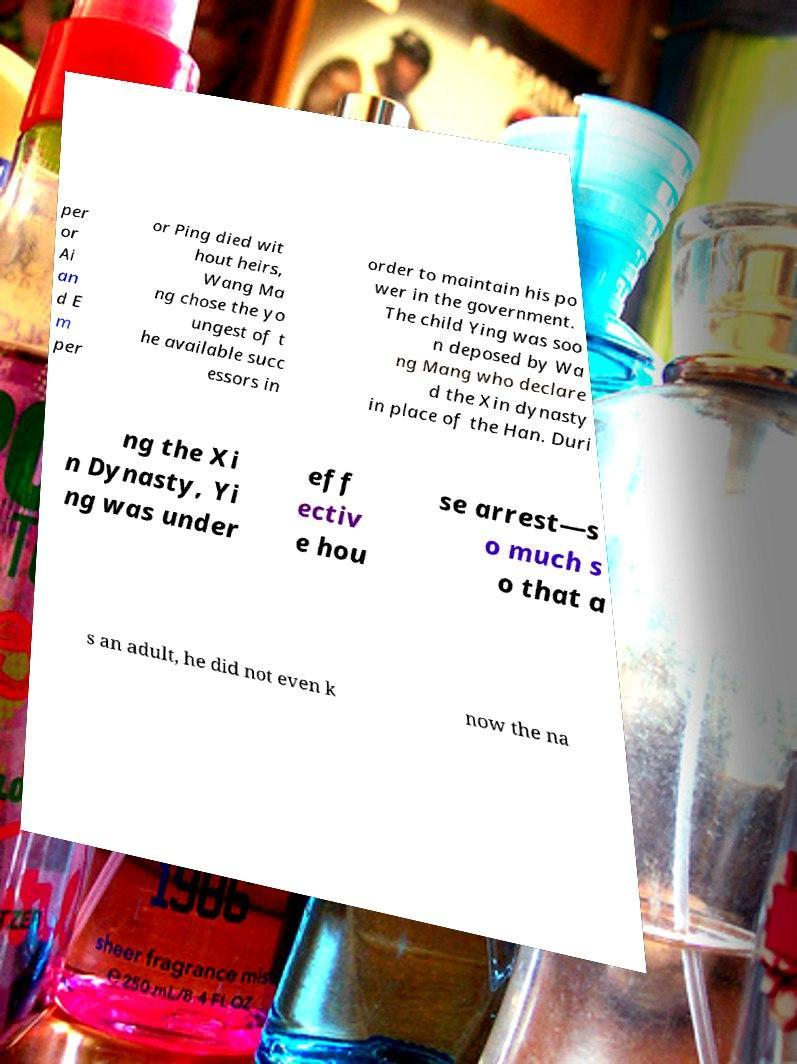I need the written content from this picture converted into text. Can you do that? per or Ai an d E m per or Ping died wit hout heirs, Wang Ma ng chose the yo ungest of t he available succ essors in order to maintain his po wer in the government. The child Ying was soo n deposed by Wa ng Mang who declare d the Xin dynasty in place of the Han. Duri ng the Xi n Dynasty, Yi ng was under eff ectiv e hou se arrest—s o much s o that a s an adult, he did not even k now the na 